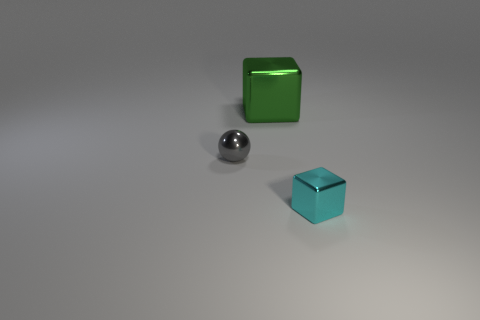What number of objects are either things on the right side of the big green metal thing or large metallic objects to the right of the tiny gray metal thing?
Ensure brevity in your answer.  2. How many other things are the same color as the small shiny sphere?
Give a very brief answer. 0. Are there more metallic cubes that are right of the big green object than tiny cubes that are to the left of the tiny cyan thing?
Your response must be concise. Yes. Is there anything else that is the same size as the green object?
Provide a short and direct response. No. How many cylinders are metal objects or small things?
Provide a succinct answer. 0. What number of things are either shiny blocks that are behind the small ball or green shiny objects?
Ensure brevity in your answer.  1. The tiny shiny thing that is behind the object that is in front of the tiny object behind the small cyan shiny block is what shape?
Keep it short and to the point. Sphere. How many small gray metallic objects are the same shape as the big thing?
Provide a short and direct response. 0. Is the material of the small gray thing the same as the green object?
Provide a short and direct response. Yes. There is a block that is on the left side of the metal object on the right side of the green metallic block; how many green things are in front of it?
Ensure brevity in your answer.  0. 